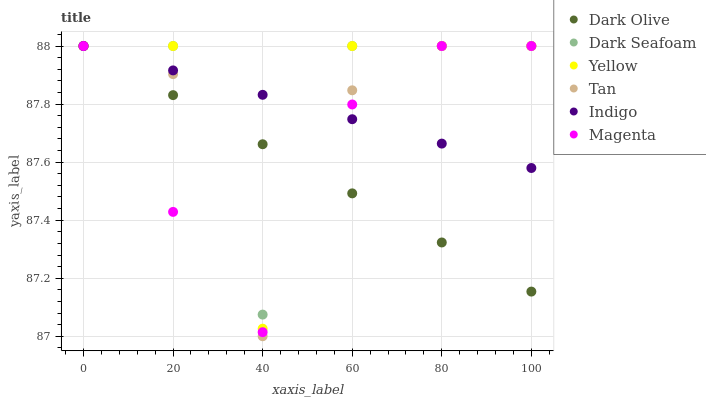Does Dark Olive have the minimum area under the curve?
Answer yes or no. Yes. Does Dark Seafoam have the maximum area under the curve?
Answer yes or no. Yes. Does Yellow have the minimum area under the curve?
Answer yes or no. No. Does Yellow have the maximum area under the curve?
Answer yes or no. No. Is Dark Olive the smoothest?
Answer yes or no. Yes. Is Yellow the roughest?
Answer yes or no. Yes. Is Yellow the smoothest?
Answer yes or no. No. Is Dark Olive the roughest?
Answer yes or no. No. Does Tan have the lowest value?
Answer yes or no. Yes. Does Dark Olive have the lowest value?
Answer yes or no. No. Does Tan have the highest value?
Answer yes or no. Yes. Does Magenta intersect Dark Olive?
Answer yes or no. Yes. Is Magenta less than Dark Olive?
Answer yes or no. No. Is Magenta greater than Dark Olive?
Answer yes or no. No. 